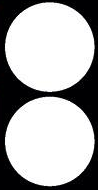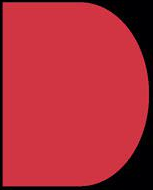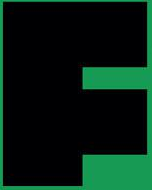Read the text from these images in sequence, separated by a semicolon. :; D; F 